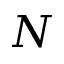<formula> <loc_0><loc_0><loc_500><loc_500>N</formula> 